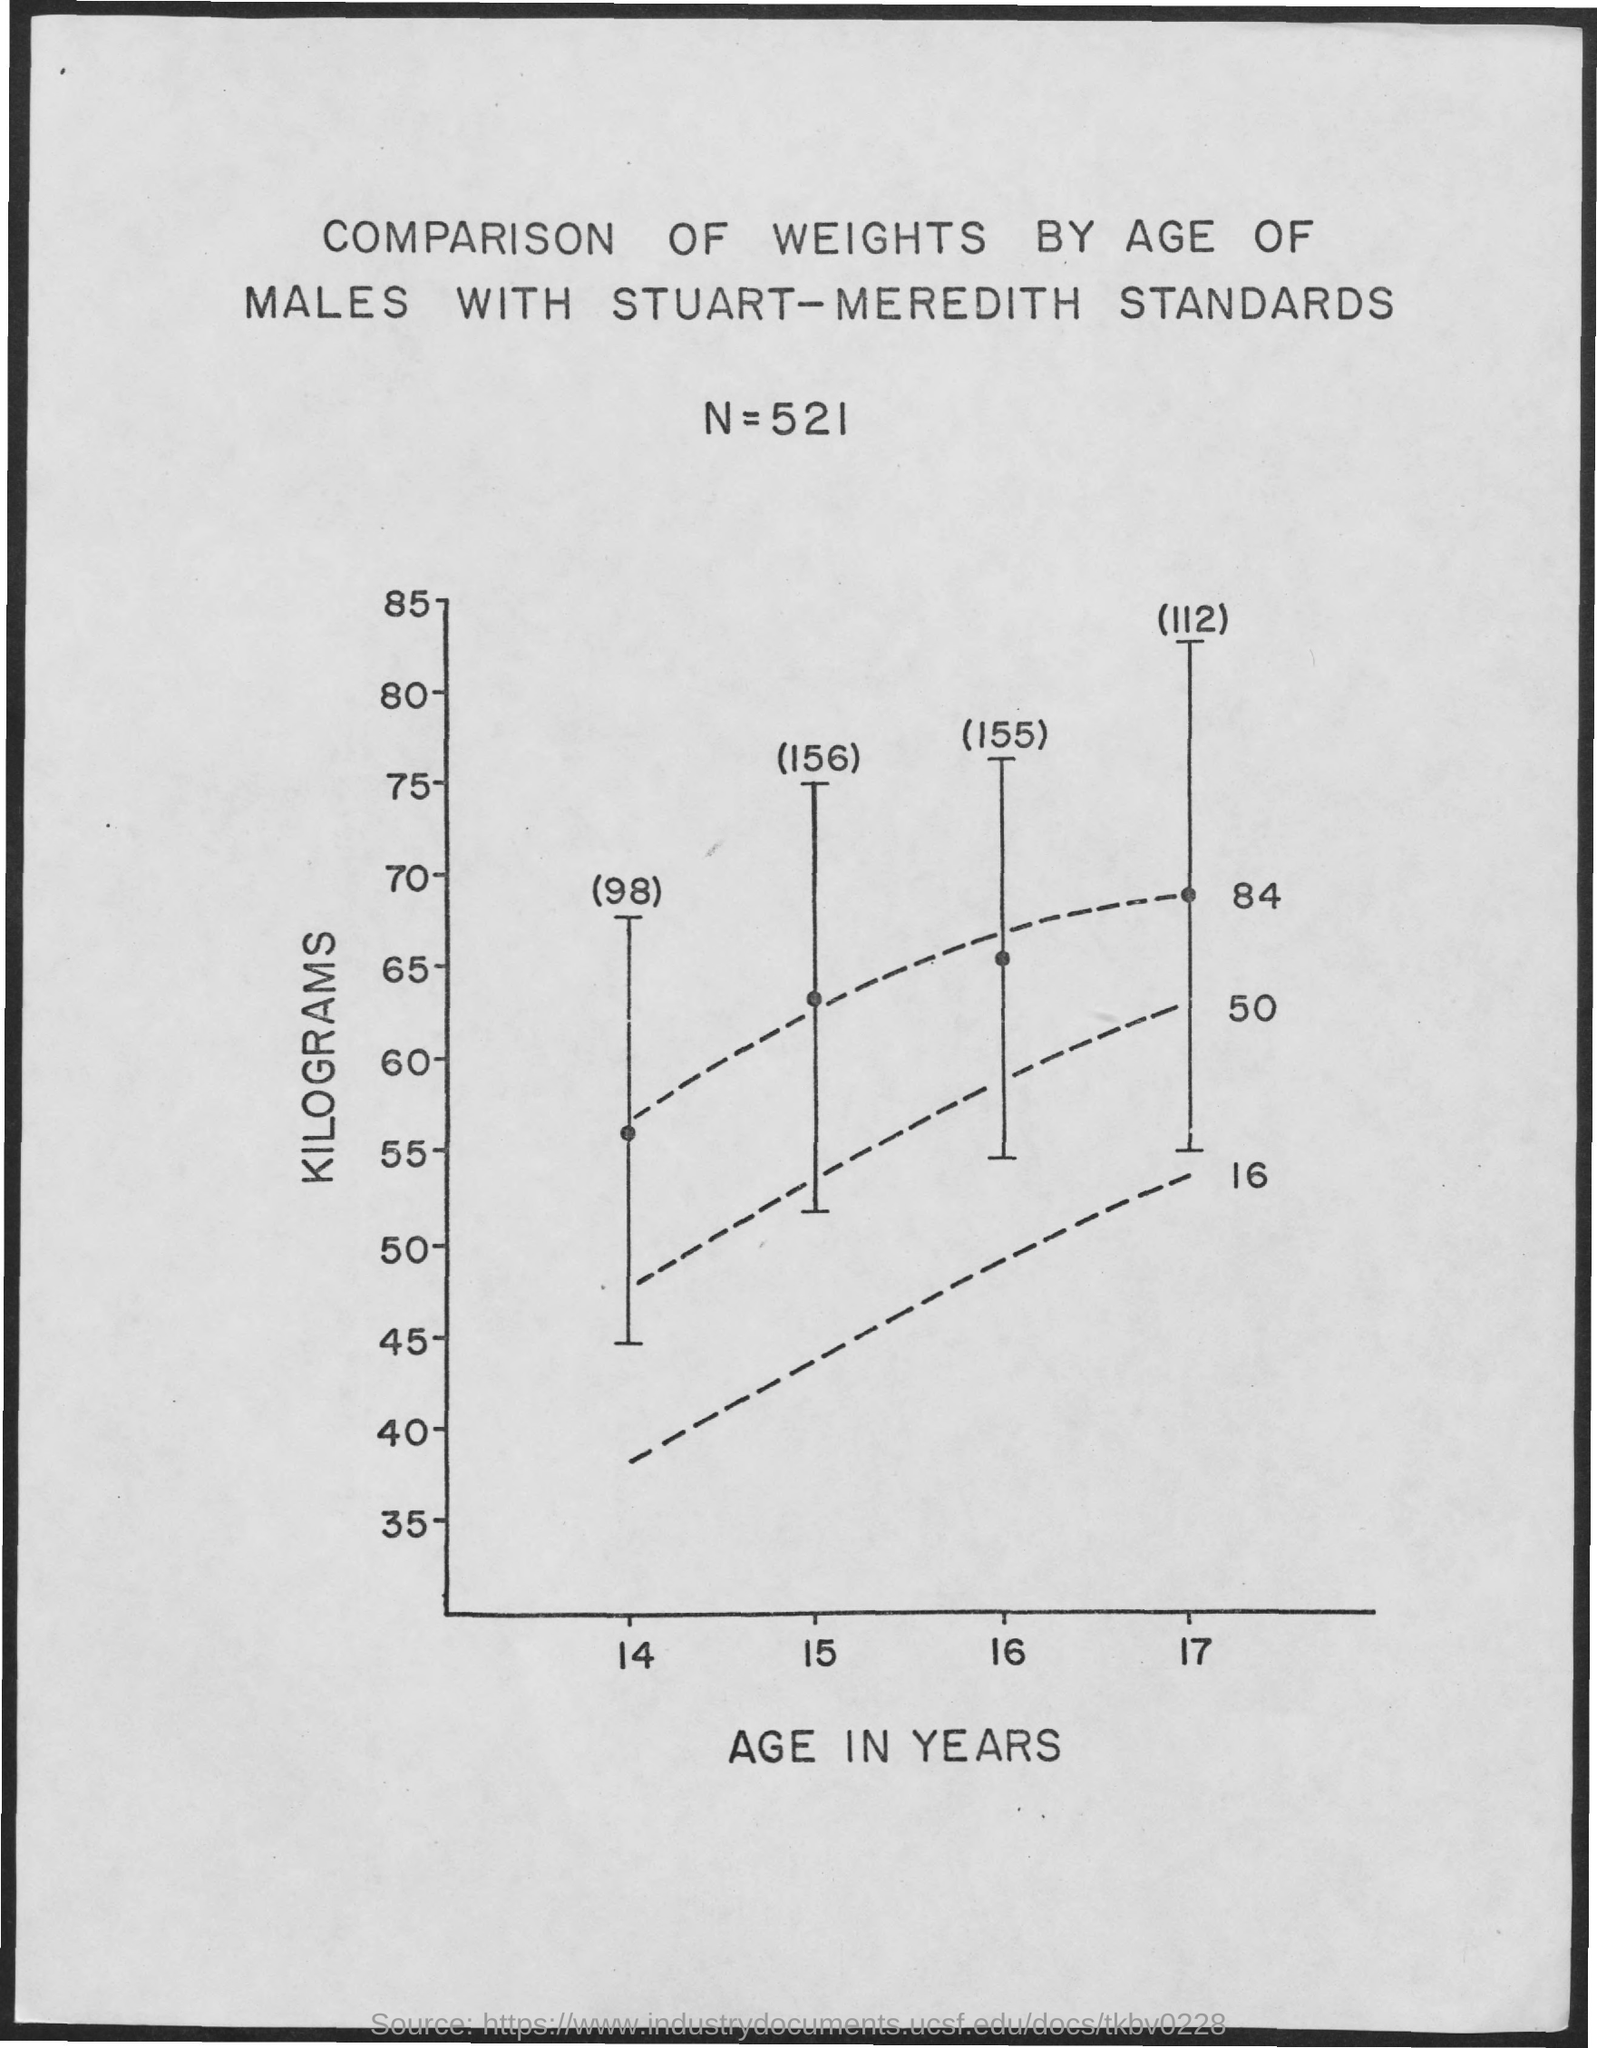Mention a couple of crucial points in this snapshot. The value of N is 521. The x-axis represents the age of individuals in years. The title of the study is "Comparison of Weights by Age of Males with Stuart-Meredith Standards. The Y-axis in the graph represents the number of kilograms of CO2 emitted by each country, with higher values indicating higher emissions. 